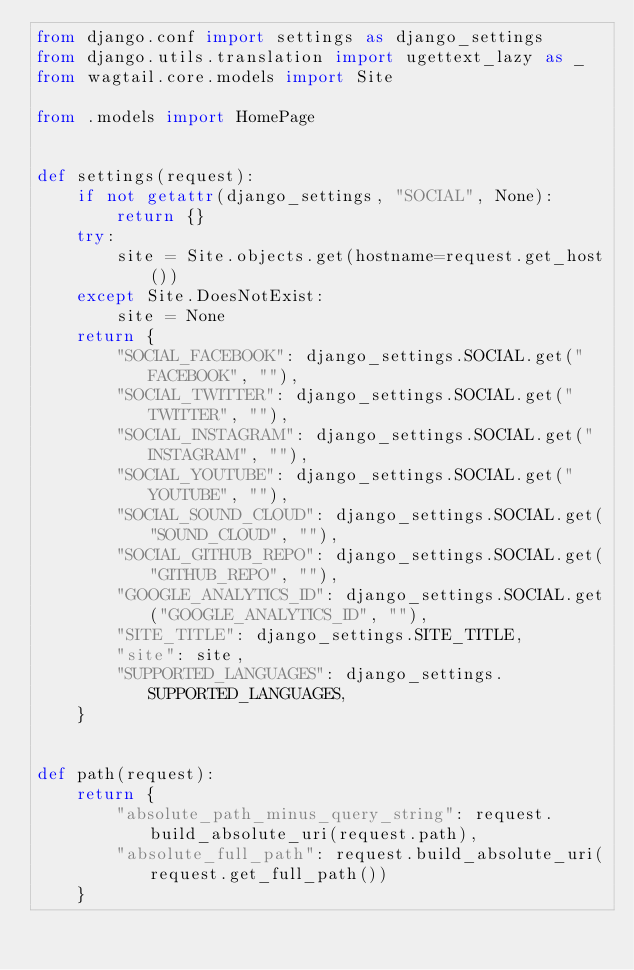<code> <loc_0><loc_0><loc_500><loc_500><_Python_>from django.conf import settings as django_settings
from django.utils.translation import ugettext_lazy as _
from wagtail.core.models import Site

from .models import HomePage


def settings(request):
    if not getattr(django_settings, "SOCIAL", None):
        return {}
    try:
        site = Site.objects.get(hostname=request.get_host())
    except Site.DoesNotExist:
        site = None
    return {
        "SOCIAL_FACEBOOK": django_settings.SOCIAL.get("FACEBOOK", ""),
        "SOCIAL_TWITTER": django_settings.SOCIAL.get("TWITTER", ""),
        "SOCIAL_INSTAGRAM": django_settings.SOCIAL.get("INSTAGRAM", ""),
        "SOCIAL_YOUTUBE": django_settings.SOCIAL.get("YOUTUBE", ""),
        "SOCIAL_SOUND_CLOUD": django_settings.SOCIAL.get("SOUND_CLOUD", ""),
        "SOCIAL_GITHUB_REPO": django_settings.SOCIAL.get("GITHUB_REPO", ""),
        "GOOGLE_ANALYTICS_ID": django_settings.SOCIAL.get("GOOGLE_ANALYTICS_ID", ""),
        "SITE_TITLE": django_settings.SITE_TITLE,
        "site": site,
        "SUPPORTED_LANGUAGES": django_settings.SUPPORTED_LANGUAGES,
    }


def path(request):
    return {
        "absolute_path_minus_query_string": request.build_absolute_uri(request.path),
        "absolute_full_path": request.build_absolute_uri(request.get_full_path())
    }
</code> 